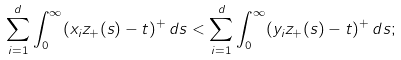<formula> <loc_0><loc_0><loc_500><loc_500>\sum _ { i = 1 } ^ { d } \int _ { 0 } ^ { \infty } ( x _ { i } z _ { + } ( s ) - t ) ^ { + } \, d s < \sum _ { i = 1 } ^ { d } \int _ { 0 } ^ { \infty } ( y _ { i } z _ { + } ( s ) - t ) ^ { + } \, d s ;</formula> 